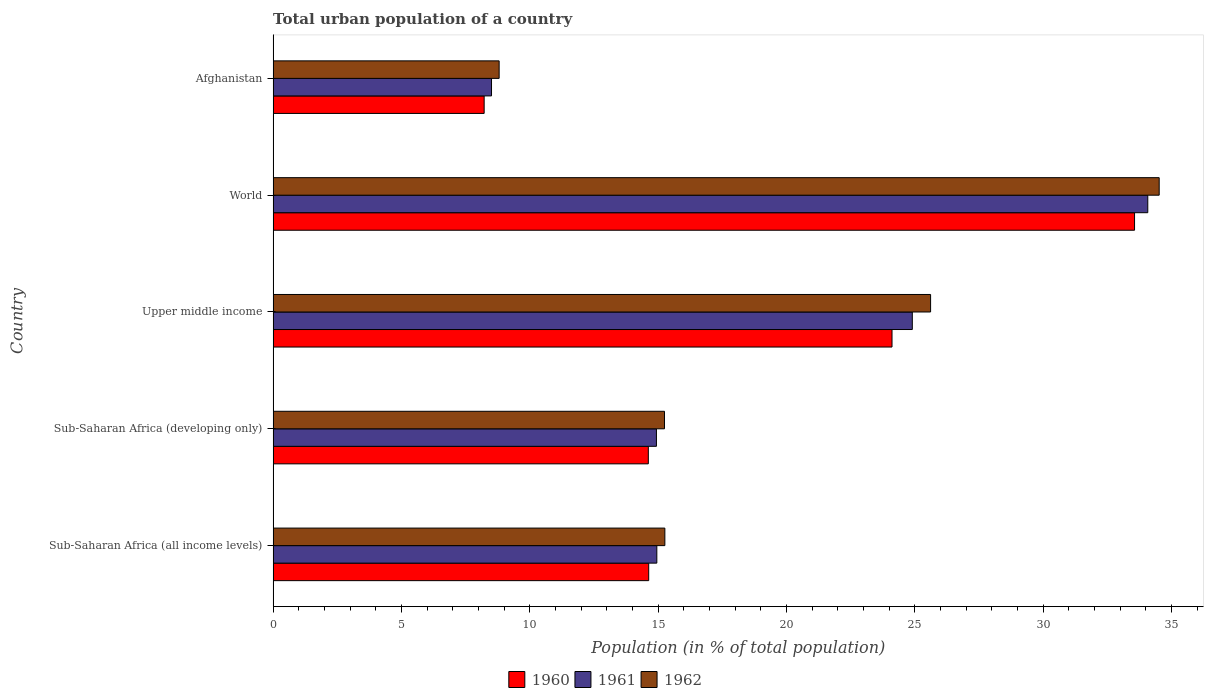How many different coloured bars are there?
Offer a very short reply. 3. How many groups of bars are there?
Provide a short and direct response. 5. Are the number of bars on each tick of the Y-axis equal?
Offer a very short reply. Yes. How many bars are there on the 4th tick from the top?
Keep it short and to the point. 3. How many bars are there on the 1st tick from the bottom?
Make the answer very short. 3. What is the label of the 1st group of bars from the top?
Ensure brevity in your answer.  Afghanistan. What is the urban population in 1961 in Sub-Saharan Africa (developing only)?
Your response must be concise. 14.93. Across all countries, what is the maximum urban population in 1960?
Your response must be concise. 33.56. Across all countries, what is the minimum urban population in 1961?
Make the answer very short. 8.51. In which country was the urban population in 1962 maximum?
Your answer should be compact. World. In which country was the urban population in 1960 minimum?
Your answer should be very brief. Afghanistan. What is the total urban population in 1960 in the graph?
Your answer should be very brief. 95.14. What is the difference between the urban population in 1961 in Sub-Saharan Africa (all income levels) and that in Upper middle income?
Provide a succinct answer. -9.95. What is the difference between the urban population in 1960 in Sub-Saharan Africa (developing only) and the urban population in 1962 in Sub-Saharan Africa (all income levels)?
Give a very brief answer. -0.64. What is the average urban population in 1960 per country?
Make the answer very short. 19.03. What is the difference between the urban population in 1961 and urban population in 1960 in World?
Give a very brief answer. 0.52. In how many countries, is the urban population in 1961 greater than 9 %?
Make the answer very short. 4. What is the ratio of the urban population in 1962 in Afghanistan to that in Sub-Saharan Africa (developing only)?
Offer a terse response. 0.58. What is the difference between the highest and the second highest urban population in 1962?
Offer a very short reply. 8.91. What is the difference between the highest and the lowest urban population in 1961?
Keep it short and to the point. 25.57. In how many countries, is the urban population in 1961 greater than the average urban population in 1961 taken over all countries?
Provide a short and direct response. 2. Is the sum of the urban population in 1962 in Afghanistan and Sub-Saharan Africa (developing only) greater than the maximum urban population in 1961 across all countries?
Keep it short and to the point. No. What does the 3rd bar from the bottom in Sub-Saharan Africa (all income levels) represents?
Offer a very short reply. 1962. Is it the case that in every country, the sum of the urban population in 1960 and urban population in 1961 is greater than the urban population in 1962?
Your response must be concise. Yes. Are all the bars in the graph horizontal?
Your answer should be very brief. Yes. How many countries are there in the graph?
Make the answer very short. 5. What is the difference between two consecutive major ticks on the X-axis?
Your response must be concise. 5. Does the graph contain any zero values?
Your answer should be compact. No. Where does the legend appear in the graph?
Offer a very short reply. Bottom center. How many legend labels are there?
Offer a very short reply. 3. How are the legend labels stacked?
Offer a terse response. Horizontal. What is the title of the graph?
Your answer should be very brief. Total urban population of a country. Does "1986" appear as one of the legend labels in the graph?
Your answer should be very brief. No. What is the label or title of the X-axis?
Your response must be concise. Population (in % of total population). What is the label or title of the Y-axis?
Make the answer very short. Country. What is the Population (in % of total population) in 1960 in Sub-Saharan Africa (all income levels)?
Your answer should be very brief. 14.63. What is the Population (in % of total population) of 1961 in Sub-Saharan Africa (all income levels)?
Ensure brevity in your answer.  14.95. What is the Population (in % of total population) of 1962 in Sub-Saharan Africa (all income levels)?
Ensure brevity in your answer.  15.26. What is the Population (in % of total population) in 1960 in Sub-Saharan Africa (developing only)?
Make the answer very short. 14.62. What is the Population (in % of total population) of 1961 in Sub-Saharan Africa (developing only)?
Offer a very short reply. 14.93. What is the Population (in % of total population) in 1962 in Sub-Saharan Africa (developing only)?
Your answer should be compact. 15.25. What is the Population (in % of total population) of 1960 in Upper middle income?
Keep it short and to the point. 24.11. What is the Population (in % of total population) in 1961 in Upper middle income?
Keep it short and to the point. 24.9. What is the Population (in % of total population) in 1962 in Upper middle income?
Keep it short and to the point. 25.61. What is the Population (in % of total population) in 1960 in World?
Offer a terse response. 33.56. What is the Population (in % of total population) of 1961 in World?
Keep it short and to the point. 34.07. What is the Population (in % of total population) in 1962 in World?
Your response must be concise. 34.52. What is the Population (in % of total population) of 1960 in Afghanistan?
Your answer should be compact. 8.22. What is the Population (in % of total population) in 1961 in Afghanistan?
Your answer should be compact. 8.51. What is the Population (in % of total population) of 1962 in Afghanistan?
Give a very brief answer. 8.8. Across all countries, what is the maximum Population (in % of total population) in 1960?
Provide a succinct answer. 33.56. Across all countries, what is the maximum Population (in % of total population) in 1961?
Keep it short and to the point. 34.07. Across all countries, what is the maximum Population (in % of total population) in 1962?
Offer a terse response. 34.52. Across all countries, what is the minimum Population (in % of total population) in 1960?
Ensure brevity in your answer.  8.22. Across all countries, what is the minimum Population (in % of total population) in 1961?
Provide a short and direct response. 8.51. Across all countries, what is the minimum Population (in % of total population) of 1962?
Offer a terse response. 8.8. What is the total Population (in % of total population) in 1960 in the graph?
Provide a succinct answer. 95.14. What is the total Population (in % of total population) in 1961 in the graph?
Offer a terse response. 97.36. What is the total Population (in % of total population) in 1962 in the graph?
Provide a succinct answer. 99.44. What is the difference between the Population (in % of total population) of 1960 in Sub-Saharan Africa (all income levels) and that in Sub-Saharan Africa (developing only)?
Offer a very short reply. 0.01. What is the difference between the Population (in % of total population) of 1961 in Sub-Saharan Africa (all income levels) and that in Sub-Saharan Africa (developing only)?
Your response must be concise. 0.01. What is the difference between the Population (in % of total population) in 1962 in Sub-Saharan Africa (all income levels) and that in Sub-Saharan Africa (developing only)?
Provide a short and direct response. 0.01. What is the difference between the Population (in % of total population) in 1960 in Sub-Saharan Africa (all income levels) and that in Upper middle income?
Offer a very short reply. -9.48. What is the difference between the Population (in % of total population) of 1961 in Sub-Saharan Africa (all income levels) and that in Upper middle income?
Offer a very short reply. -9.95. What is the difference between the Population (in % of total population) of 1962 in Sub-Saharan Africa (all income levels) and that in Upper middle income?
Your response must be concise. -10.35. What is the difference between the Population (in % of total population) of 1960 in Sub-Saharan Africa (all income levels) and that in World?
Offer a terse response. -18.93. What is the difference between the Population (in % of total population) of 1961 in Sub-Saharan Africa (all income levels) and that in World?
Provide a short and direct response. -19.13. What is the difference between the Population (in % of total population) of 1962 in Sub-Saharan Africa (all income levels) and that in World?
Offer a very short reply. -19.26. What is the difference between the Population (in % of total population) of 1960 in Sub-Saharan Africa (all income levels) and that in Afghanistan?
Provide a succinct answer. 6.41. What is the difference between the Population (in % of total population) in 1961 in Sub-Saharan Africa (all income levels) and that in Afghanistan?
Ensure brevity in your answer.  6.44. What is the difference between the Population (in % of total population) of 1962 in Sub-Saharan Africa (all income levels) and that in Afghanistan?
Your answer should be compact. 6.46. What is the difference between the Population (in % of total population) in 1960 in Sub-Saharan Africa (developing only) and that in Upper middle income?
Ensure brevity in your answer.  -9.49. What is the difference between the Population (in % of total population) of 1961 in Sub-Saharan Africa (developing only) and that in Upper middle income?
Offer a terse response. -9.97. What is the difference between the Population (in % of total population) of 1962 in Sub-Saharan Africa (developing only) and that in Upper middle income?
Your response must be concise. -10.37. What is the difference between the Population (in % of total population) in 1960 in Sub-Saharan Africa (developing only) and that in World?
Your response must be concise. -18.94. What is the difference between the Population (in % of total population) of 1961 in Sub-Saharan Africa (developing only) and that in World?
Give a very brief answer. -19.14. What is the difference between the Population (in % of total population) of 1962 in Sub-Saharan Africa (developing only) and that in World?
Provide a short and direct response. -19.27. What is the difference between the Population (in % of total population) of 1960 in Sub-Saharan Africa (developing only) and that in Afghanistan?
Keep it short and to the point. 6.4. What is the difference between the Population (in % of total population) in 1961 in Sub-Saharan Africa (developing only) and that in Afghanistan?
Offer a terse response. 6.42. What is the difference between the Population (in % of total population) in 1962 in Sub-Saharan Africa (developing only) and that in Afghanistan?
Offer a terse response. 6.44. What is the difference between the Population (in % of total population) in 1960 in Upper middle income and that in World?
Offer a terse response. -9.45. What is the difference between the Population (in % of total population) of 1961 in Upper middle income and that in World?
Your answer should be compact. -9.17. What is the difference between the Population (in % of total population) of 1962 in Upper middle income and that in World?
Provide a succinct answer. -8.91. What is the difference between the Population (in % of total population) of 1960 in Upper middle income and that in Afghanistan?
Make the answer very short. 15.89. What is the difference between the Population (in % of total population) in 1961 in Upper middle income and that in Afghanistan?
Offer a terse response. 16.39. What is the difference between the Population (in % of total population) in 1962 in Upper middle income and that in Afghanistan?
Offer a very short reply. 16.81. What is the difference between the Population (in % of total population) of 1960 in World and that in Afghanistan?
Your answer should be compact. 25.34. What is the difference between the Population (in % of total population) in 1961 in World and that in Afghanistan?
Your answer should be compact. 25.57. What is the difference between the Population (in % of total population) in 1962 in World and that in Afghanistan?
Make the answer very short. 25.71. What is the difference between the Population (in % of total population) in 1960 in Sub-Saharan Africa (all income levels) and the Population (in % of total population) in 1961 in Sub-Saharan Africa (developing only)?
Provide a succinct answer. -0.3. What is the difference between the Population (in % of total population) in 1960 in Sub-Saharan Africa (all income levels) and the Population (in % of total population) in 1962 in Sub-Saharan Africa (developing only)?
Make the answer very short. -0.61. What is the difference between the Population (in % of total population) of 1961 in Sub-Saharan Africa (all income levels) and the Population (in % of total population) of 1962 in Sub-Saharan Africa (developing only)?
Your response must be concise. -0.3. What is the difference between the Population (in % of total population) in 1960 in Sub-Saharan Africa (all income levels) and the Population (in % of total population) in 1961 in Upper middle income?
Keep it short and to the point. -10.27. What is the difference between the Population (in % of total population) of 1960 in Sub-Saharan Africa (all income levels) and the Population (in % of total population) of 1962 in Upper middle income?
Ensure brevity in your answer.  -10.98. What is the difference between the Population (in % of total population) of 1961 in Sub-Saharan Africa (all income levels) and the Population (in % of total population) of 1962 in Upper middle income?
Offer a terse response. -10.67. What is the difference between the Population (in % of total population) of 1960 in Sub-Saharan Africa (all income levels) and the Population (in % of total population) of 1961 in World?
Offer a very short reply. -19.44. What is the difference between the Population (in % of total population) in 1960 in Sub-Saharan Africa (all income levels) and the Population (in % of total population) in 1962 in World?
Make the answer very short. -19.89. What is the difference between the Population (in % of total population) of 1961 in Sub-Saharan Africa (all income levels) and the Population (in % of total population) of 1962 in World?
Offer a terse response. -19.57. What is the difference between the Population (in % of total population) in 1960 in Sub-Saharan Africa (all income levels) and the Population (in % of total population) in 1961 in Afghanistan?
Make the answer very short. 6.12. What is the difference between the Population (in % of total population) of 1960 in Sub-Saharan Africa (all income levels) and the Population (in % of total population) of 1962 in Afghanistan?
Your response must be concise. 5.83. What is the difference between the Population (in % of total population) in 1961 in Sub-Saharan Africa (all income levels) and the Population (in % of total population) in 1962 in Afghanistan?
Give a very brief answer. 6.14. What is the difference between the Population (in % of total population) of 1960 in Sub-Saharan Africa (developing only) and the Population (in % of total population) of 1961 in Upper middle income?
Your response must be concise. -10.28. What is the difference between the Population (in % of total population) of 1960 in Sub-Saharan Africa (developing only) and the Population (in % of total population) of 1962 in Upper middle income?
Your answer should be compact. -11. What is the difference between the Population (in % of total population) in 1961 in Sub-Saharan Africa (developing only) and the Population (in % of total population) in 1962 in Upper middle income?
Give a very brief answer. -10.68. What is the difference between the Population (in % of total population) in 1960 in Sub-Saharan Africa (developing only) and the Population (in % of total population) in 1961 in World?
Offer a terse response. -19.46. What is the difference between the Population (in % of total population) in 1960 in Sub-Saharan Africa (developing only) and the Population (in % of total population) in 1962 in World?
Your response must be concise. -19.9. What is the difference between the Population (in % of total population) in 1961 in Sub-Saharan Africa (developing only) and the Population (in % of total population) in 1962 in World?
Give a very brief answer. -19.59. What is the difference between the Population (in % of total population) in 1960 in Sub-Saharan Africa (developing only) and the Population (in % of total population) in 1961 in Afghanistan?
Offer a very short reply. 6.11. What is the difference between the Population (in % of total population) of 1960 in Sub-Saharan Africa (developing only) and the Population (in % of total population) of 1962 in Afghanistan?
Ensure brevity in your answer.  5.81. What is the difference between the Population (in % of total population) in 1961 in Sub-Saharan Africa (developing only) and the Population (in % of total population) in 1962 in Afghanistan?
Provide a short and direct response. 6.13. What is the difference between the Population (in % of total population) in 1960 in Upper middle income and the Population (in % of total population) in 1961 in World?
Offer a very short reply. -9.96. What is the difference between the Population (in % of total population) of 1960 in Upper middle income and the Population (in % of total population) of 1962 in World?
Offer a very short reply. -10.41. What is the difference between the Population (in % of total population) in 1961 in Upper middle income and the Population (in % of total population) in 1962 in World?
Offer a very short reply. -9.62. What is the difference between the Population (in % of total population) of 1960 in Upper middle income and the Population (in % of total population) of 1961 in Afghanistan?
Provide a succinct answer. 15.6. What is the difference between the Population (in % of total population) of 1960 in Upper middle income and the Population (in % of total population) of 1962 in Afghanistan?
Your response must be concise. 15.3. What is the difference between the Population (in % of total population) of 1961 in Upper middle income and the Population (in % of total population) of 1962 in Afghanistan?
Provide a short and direct response. 16.1. What is the difference between the Population (in % of total population) in 1960 in World and the Population (in % of total population) in 1961 in Afghanistan?
Your answer should be compact. 25.05. What is the difference between the Population (in % of total population) in 1960 in World and the Population (in % of total population) in 1962 in Afghanistan?
Give a very brief answer. 24.75. What is the difference between the Population (in % of total population) in 1961 in World and the Population (in % of total population) in 1962 in Afghanistan?
Provide a short and direct response. 25.27. What is the average Population (in % of total population) of 1960 per country?
Provide a short and direct response. 19.03. What is the average Population (in % of total population) of 1961 per country?
Ensure brevity in your answer.  19.47. What is the average Population (in % of total population) of 1962 per country?
Provide a succinct answer. 19.89. What is the difference between the Population (in % of total population) of 1960 and Population (in % of total population) of 1961 in Sub-Saharan Africa (all income levels)?
Provide a short and direct response. -0.32. What is the difference between the Population (in % of total population) of 1960 and Population (in % of total population) of 1962 in Sub-Saharan Africa (all income levels)?
Your response must be concise. -0.63. What is the difference between the Population (in % of total population) in 1961 and Population (in % of total population) in 1962 in Sub-Saharan Africa (all income levels)?
Provide a short and direct response. -0.31. What is the difference between the Population (in % of total population) in 1960 and Population (in % of total population) in 1961 in Sub-Saharan Africa (developing only)?
Provide a succinct answer. -0.32. What is the difference between the Population (in % of total population) in 1960 and Population (in % of total population) in 1962 in Sub-Saharan Africa (developing only)?
Offer a terse response. -0.63. What is the difference between the Population (in % of total population) in 1961 and Population (in % of total population) in 1962 in Sub-Saharan Africa (developing only)?
Provide a short and direct response. -0.31. What is the difference between the Population (in % of total population) of 1960 and Population (in % of total population) of 1961 in Upper middle income?
Provide a short and direct response. -0.79. What is the difference between the Population (in % of total population) of 1960 and Population (in % of total population) of 1962 in Upper middle income?
Provide a succinct answer. -1.5. What is the difference between the Population (in % of total population) of 1961 and Population (in % of total population) of 1962 in Upper middle income?
Provide a short and direct response. -0.71. What is the difference between the Population (in % of total population) in 1960 and Population (in % of total population) in 1961 in World?
Provide a short and direct response. -0.52. What is the difference between the Population (in % of total population) in 1960 and Population (in % of total population) in 1962 in World?
Offer a very short reply. -0.96. What is the difference between the Population (in % of total population) of 1961 and Population (in % of total population) of 1962 in World?
Ensure brevity in your answer.  -0.44. What is the difference between the Population (in % of total population) of 1960 and Population (in % of total population) of 1961 in Afghanistan?
Offer a terse response. -0.29. What is the difference between the Population (in % of total population) in 1960 and Population (in % of total population) in 1962 in Afghanistan?
Offer a very short reply. -0.58. What is the difference between the Population (in % of total population) of 1961 and Population (in % of total population) of 1962 in Afghanistan?
Ensure brevity in your answer.  -0.3. What is the ratio of the Population (in % of total population) in 1960 in Sub-Saharan Africa (all income levels) to that in Sub-Saharan Africa (developing only)?
Your answer should be very brief. 1. What is the ratio of the Population (in % of total population) in 1961 in Sub-Saharan Africa (all income levels) to that in Sub-Saharan Africa (developing only)?
Make the answer very short. 1. What is the ratio of the Population (in % of total population) of 1962 in Sub-Saharan Africa (all income levels) to that in Sub-Saharan Africa (developing only)?
Offer a terse response. 1. What is the ratio of the Population (in % of total population) in 1960 in Sub-Saharan Africa (all income levels) to that in Upper middle income?
Give a very brief answer. 0.61. What is the ratio of the Population (in % of total population) of 1961 in Sub-Saharan Africa (all income levels) to that in Upper middle income?
Your response must be concise. 0.6. What is the ratio of the Population (in % of total population) in 1962 in Sub-Saharan Africa (all income levels) to that in Upper middle income?
Give a very brief answer. 0.6. What is the ratio of the Population (in % of total population) of 1960 in Sub-Saharan Africa (all income levels) to that in World?
Your response must be concise. 0.44. What is the ratio of the Population (in % of total population) in 1961 in Sub-Saharan Africa (all income levels) to that in World?
Ensure brevity in your answer.  0.44. What is the ratio of the Population (in % of total population) in 1962 in Sub-Saharan Africa (all income levels) to that in World?
Offer a very short reply. 0.44. What is the ratio of the Population (in % of total population) in 1960 in Sub-Saharan Africa (all income levels) to that in Afghanistan?
Offer a very short reply. 1.78. What is the ratio of the Population (in % of total population) of 1961 in Sub-Saharan Africa (all income levels) to that in Afghanistan?
Provide a short and direct response. 1.76. What is the ratio of the Population (in % of total population) in 1962 in Sub-Saharan Africa (all income levels) to that in Afghanistan?
Give a very brief answer. 1.73. What is the ratio of the Population (in % of total population) of 1960 in Sub-Saharan Africa (developing only) to that in Upper middle income?
Your answer should be compact. 0.61. What is the ratio of the Population (in % of total population) of 1961 in Sub-Saharan Africa (developing only) to that in Upper middle income?
Make the answer very short. 0.6. What is the ratio of the Population (in % of total population) in 1962 in Sub-Saharan Africa (developing only) to that in Upper middle income?
Keep it short and to the point. 0.6. What is the ratio of the Population (in % of total population) in 1960 in Sub-Saharan Africa (developing only) to that in World?
Ensure brevity in your answer.  0.44. What is the ratio of the Population (in % of total population) of 1961 in Sub-Saharan Africa (developing only) to that in World?
Keep it short and to the point. 0.44. What is the ratio of the Population (in % of total population) in 1962 in Sub-Saharan Africa (developing only) to that in World?
Give a very brief answer. 0.44. What is the ratio of the Population (in % of total population) of 1960 in Sub-Saharan Africa (developing only) to that in Afghanistan?
Keep it short and to the point. 1.78. What is the ratio of the Population (in % of total population) in 1961 in Sub-Saharan Africa (developing only) to that in Afghanistan?
Keep it short and to the point. 1.76. What is the ratio of the Population (in % of total population) in 1962 in Sub-Saharan Africa (developing only) to that in Afghanistan?
Keep it short and to the point. 1.73. What is the ratio of the Population (in % of total population) in 1960 in Upper middle income to that in World?
Offer a very short reply. 0.72. What is the ratio of the Population (in % of total population) of 1961 in Upper middle income to that in World?
Offer a terse response. 0.73. What is the ratio of the Population (in % of total population) in 1962 in Upper middle income to that in World?
Make the answer very short. 0.74. What is the ratio of the Population (in % of total population) in 1960 in Upper middle income to that in Afghanistan?
Your response must be concise. 2.93. What is the ratio of the Population (in % of total population) in 1961 in Upper middle income to that in Afghanistan?
Give a very brief answer. 2.93. What is the ratio of the Population (in % of total population) in 1962 in Upper middle income to that in Afghanistan?
Offer a terse response. 2.91. What is the ratio of the Population (in % of total population) in 1960 in World to that in Afghanistan?
Give a very brief answer. 4.08. What is the ratio of the Population (in % of total population) of 1961 in World to that in Afghanistan?
Your answer should be compact. 4. What is the ratio of the Population (in % of total population) in 1962 in World to that in Afghanistan?
Your answer should be compact. 3.92. What is the difference between the highest and the second highest Population (in % of total population) of 1960?
Provide a succinct answer. 9.45. What is the difference between the highest and the second highest Population (in % of total population) of 1961?
Provide a short and direct response. 9.17. What is the difference between the highest and the second highest Population (in % of total population) in 1962?
Offer a very short reply. 8.91. What is the difference between the highest and the lowest Population (in % of total population) in 1960?
Make the answer very short. 25.34. What is the difference between the highest and the lowest Population (in % of total population) of 1961?
Your answer should be compact. 25.57. What is the difference between the highest and the lowest Population (in % of total population) of 1962?
Ensure brevity in your answer.  25.71. 